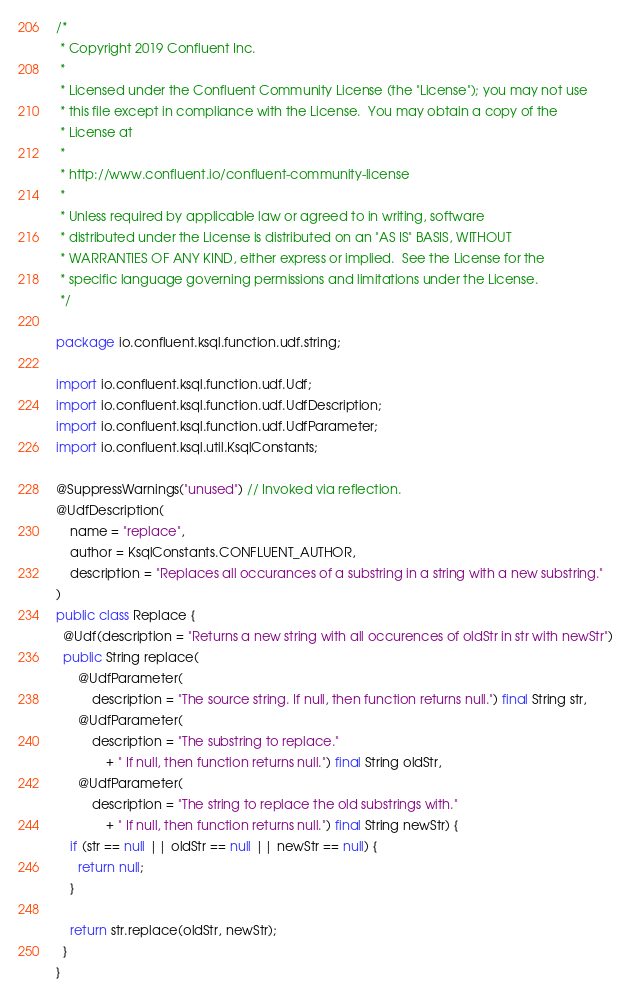Convert code to text. <code><loc_0><loc_0><loc_500><loc_500><_Java_>/*
 * Copyright 2019 Confluent Inc.
 *
 * Licensed under the Confluent Community License (the "License"); you may not use
 * this file except in compliance with the License.  You may obtain a copy of the
 * License at
 *
 * http://www.confluent.io/confluent-community-license
 *
 * Unless required by applicable law or agreed to in writing, software
 * distributed under the License is distributed on an "AS IS" BASIS, WITHOUT
 * WARRANTIES OF ANY KIND, either express or implied.  See the License for the
 * specific language governing permissions and limitations under the License.
 */

package io.confluent.ksql.function.udf.string;

import io.confluent.ksql.function.udf.Udf;
import io.confluent.ksql.function.udf.UdfDescription;
import io.confluent.ksql.function.udf.UdfParameter;
import io.confluent.ksql.util.KsqlConstants;

@SuppressWarnings("unused") // Invoked via reflection.
@UdfDescription(
    name = "replace",
    author = KsqlConstants.CONFLUENT_AUTHOR,
    description = "Replaces all occurances of a substring in a string with a new substring."
)
public class Replace {
  @Udf(description = "Returns a new string with all occurences of oldStr in str with newStr")
  public String replace(
      @UdfParameter(
          description = "The source string. If null, then function returns null.") final String str,
      @UdfParameter(
          description = "The substring to replace."
              + " If null, then function returns null.") final String oldStr,
      @UdfParameter(
          description = "The string to replace the old substrings with."
              + " If null, then function returns null.") final String newStr) {
    if (str == null || oldStr == null || newStr == null) {
      return null;
    }

    return str.replace(oldStr, newStr);
  }
}
</code> 